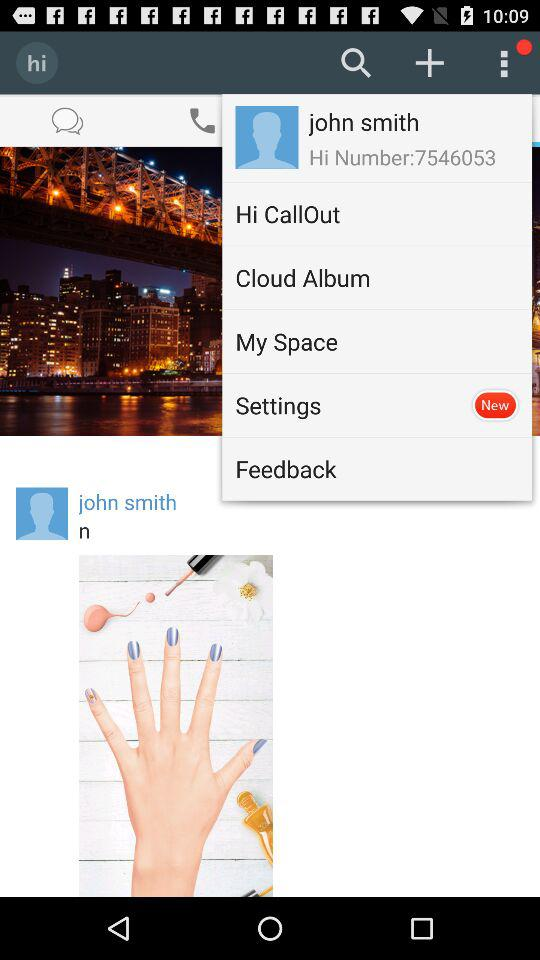What is the name of the user? The name of the user is John Smith. 